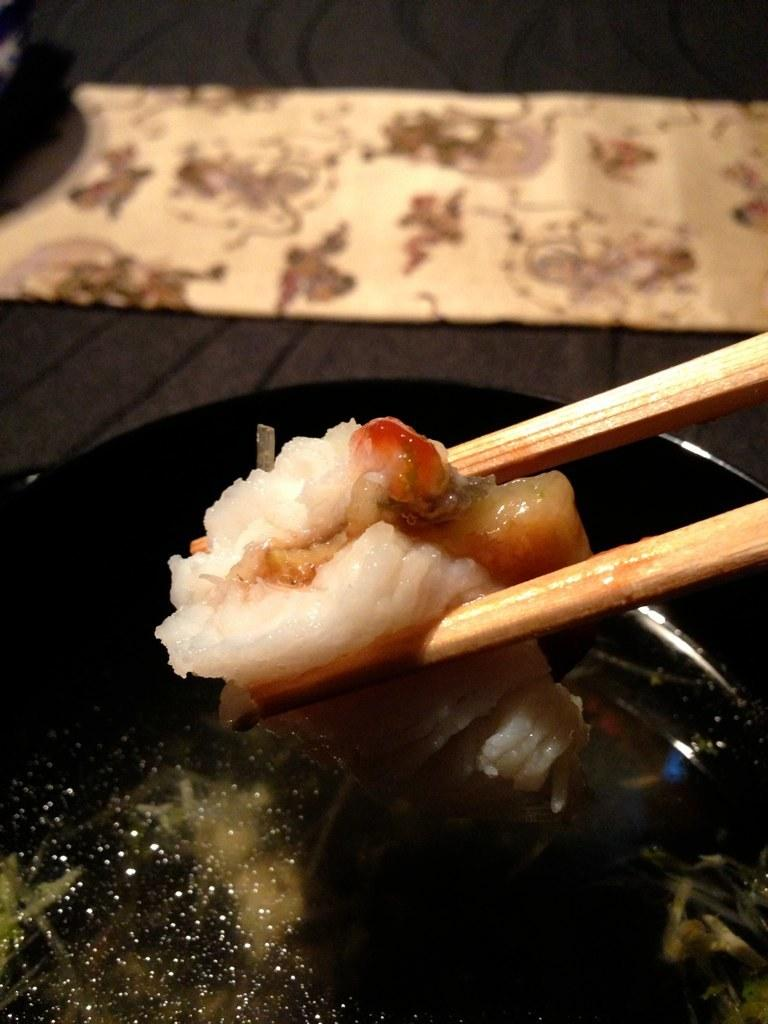What type of food material is visible in the image? There is food material in the image, but the specific type is not mentioned. How is the food material being held in the image? The food material is held with chopsticks. What type of container is present in the image? There is a bowl in the image. What is the color of the bowl? The bowl is black in color. What type of silver material is present in the image? There is no silver material present in the image. What is the profit margin of the food material in the image? The profit margin of the food material cannot be determined from the image. 